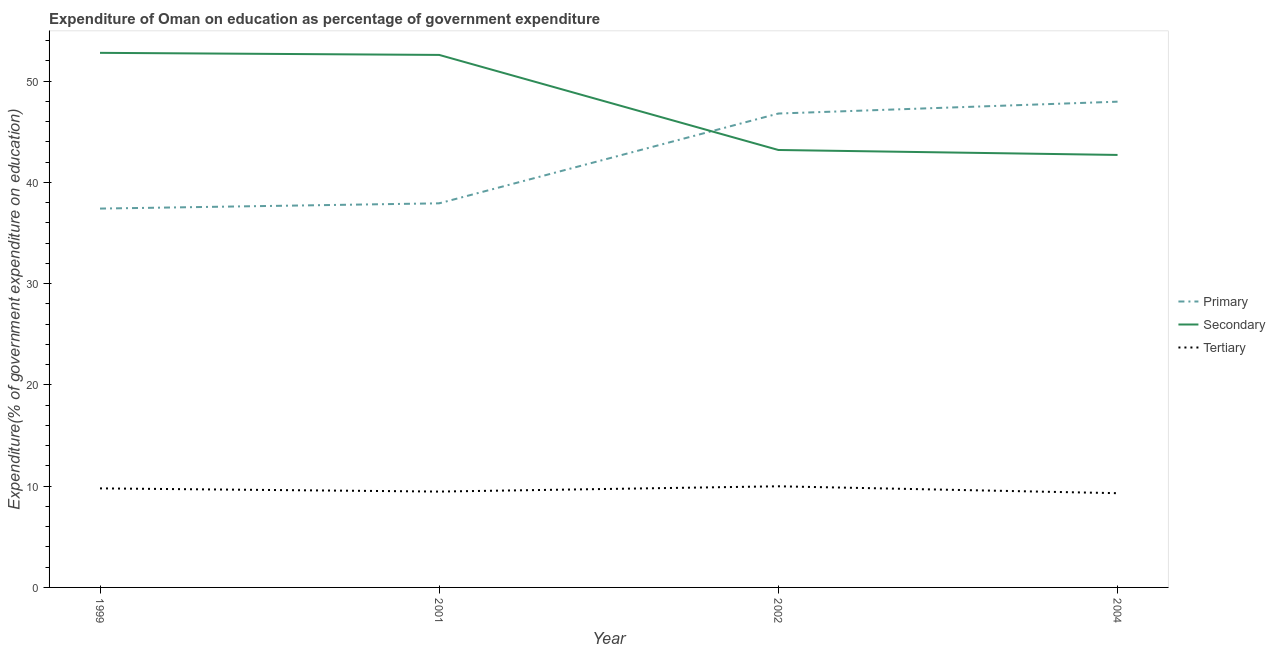How many different coloured lines are there?
Offer a terse response. 3. Is the number of lines equal to the number of legend labels?
Provide a succinct answer. Yes. What is the expenditure on tertiary education in 2004?
Make the answer very short. 9.31. Across all years, what is the maximum expenditure on secondary education?
Your response must be concise. 52.8. Across all years, what is the minimum expenditure on secondary education?
Provide a succinct answer. 42.72. In which year was the expenditure on primary education maximum?
Your answer should be very brief. 2004. What is the total expenditure on primary education in the graph?
Offer a terse response. 170.14. What is the difference between the expenditure on tertiary education in 1999 and that in 2002?
Your response must be concise. -0.21. What is the difference between the expenditure on tertiary education in 1999 and the expenditure on secondary education in 2001?
Your answer should be very brief. -42.81. What is the average expenditure on tertiary education per year?
Your answer should be compact. 9.64. In the year 2001, what is the difference between the expenditure on primary education and expenditure on tertiary education?
Keep it short and to the point. 28.47. What is the ratio of the expenditure on tertiary education in 1999 to that in 2004?
Your answer should be compact. 1.05. What is the difference between the highest and the second highest expenditure on primary education?
Keep it short and to the point. 1.17. What is the difference between the highest and the lowest expenditure on tertiary education?
Offer a very short reply. 0.68. In how many years, is the expenditure on secondary education greater than the average expenditure on secondary education taken over all years?
Offer a very short reply. 2. Is it the case that in every year, the sum of the expenditure on primary education and expenditure on secondary education is greater than the expenditure on tertiary education?
Provide a succinct answer. Yes. Does the expenditure on tertiary education monotonically increase over the years?
Your answer should be compact. No. Is the expenditure on primary education strictly greater than the expenditure on tertiary education over the years?
Your response must be concise. Yes. Is the expenditure on tertiary education strictly less than the expenditure on secondary education over the years?
Provide a succinct answer. Yes. What is the difference between two consecutive major ticks on the Y-axis?
Provide a succinct answer. 10. Are the values on the major ticks of Y-axis written in scientific E-notation?
Provide a succinct answer. No. Where does the legend appear in the graph?
Keep it short and to the point. Center right. How many legend labels are there?
Keep it short and to the point. 3. What is the title of the graph?
Provide a succinct answer. Expenditure of Oman on education as percentage of government expenditure. Does "Agricultural raw materials" appear as one of the legend labels in the graph?
Make the answer very short. No. What is the label or title of the Y-axis?
Offer a terse response. Expenditure(% of government expenditure on education). What is the Expenditure(% of government expenditure on education) of Primary in 1999?
Ensure brevity in your answer.  37.42. What is the Expenditure(% of government expenditure on education) of Secondary in 1999?
Provide a succinct answer. 52.8. What is the Expenditure(% of government expenditure on education) in Tertiary in 1999?
Keep it short and to the point. 9.78. What is the Expenditure(% of government expenditure on education) of Primary in 2001?
Offer a very short reply. 37.94. What is the Expenditure(% of government expenditure on education) in Secondary in 2001?
Provide a succinct answer. 52.59. What is the Expenditure(% of government expenditure on education) in Tertiary in 2001?
Offer a very short reply. 9.47. What is the Expenditure(% of government expenditure on education) in Primary in 2002?
Give a very brief answer. 46.81. What is the Expenditure(% of government expenditure on education) of Secondary in 2002?
Provide a succinct answer. 43.21. What is the Expenditure(% of government expenditure on education) of Tertiary in 2002?
Keep it short and to the point. 9.99. What is the Expenditure(% of government expenditure on education) of Primary in 2004?
Your answer should be very brief. 47.98. What is the Expenditure(% of government expenditure on education) of Secondary in 2004?
Your answer should be very brief. 42.72. What is the Expenditure(% of government expenditure on education) of Tertiary in 2004?
Your response must be concise. 9.31. Across all years, what is the maximum Expenditure(% of government expenditure on education) in Primary?
Keep it short and to the point. 47.98. Across all years, what is the maximum Expenditure(% of government expenditure on education) in Secondary?
Make the answer very short. 52.8. Across all years, what is the maximum Expenditure(% of government expenditure on education) of Tertiary?
Provide a succinct answer. 9.99. Across all years, what is the minimum Expenditure(% of government expenditure on education) in Primary?
Your answer should be very brief. 37.42. Across all years, what is the minimum Expenditure(% of government expenditure on education) in Secondary?
Provide a short and direct response. 42.72. Across all years, what is the minimum Expenditure(% of government expenditure on education) of Tertiary?
Offer a terse response. 9.31. What is the total Expenditure(% of government expenditure on education) of Primary in the graph?
Keep it short and to the point. 170.14. What is the total Expenditure(% of government expenditure on education) in Secondary in the graph?
Make the answer very short. 191.32. What is the total Expenditure(% of government expenditure on education) in Tertiary in the graph?
Provide a short and direct response. 38.55. What is the difference between the Expenditure(% of government expenditure on education) in Primary in 1999 and that in 2001?
Provide a succinct answer. -0.52. What is the difference between the Expenditure(% of government expenditure on education) in Secondary in 1999 and that in 2001?
Your answer should be compact. 0.21. What is the difference between the Expenditure(% of government expenditure on education) in Tertiary in 1999 and that in 2001?
Your response must be concise. 0.31. What is the difference between the Expenditure(% of government expenditure on education) in Primary in 1999 and that in 2002?
Your answer should be compact. -9.39. What is the difference between the Expenditure(% of government expenditure on education) of Secondary in 1999 and that in 2002?
Keep it short and to the point. 9.59. What is the difference between the Expenditure(% of government expenditure on education) in Tertiary in 1999 and that in 2002?
Offer a terse response. -0.21. What is the difference between the Expenditure(% of government expenditure on education) in Primary in 1999 and that in 2004?
Keep it short and to the point. -10.56. What is the difference between the Expenditure(% of government expenditure on education) of Secondary in 1999 and that in 2004?
Make the answer very short. 10.08. What is the difference between the Expenditure(% of government expenditure on education) of Tertiary in 1999 and that in 2004?
Offer a terse response. 0.48. What is the difference between the Expenditure(% of government expenditure on education) in Primary in 2001 and that in 2002?
Provide a short and direct response. -8.87. What is the difference between the Expenditure(% of government expenditure on education) in Secondary in 2001 and that in 2002?
Your answer should be very brief. 9.39. What is the difference between the Expenditure(% of government expenditure on education) in Tertiary in 2001 and that in 2002?
Give a very brief answer. -0.52. What is the difference between the Expenditure(% of government expenditure on education) of Primary in 2001 and that in 2004?
Give a very brief answer. -10.04. What is the difference between the Expenditure(% of government expenditure on education) in Secondary in 2001 and that in 2004?
Your answer should be compact. 9.88. What is the difference between the Expenditure(% of government expenditure on education) of Tertiary in 2001 and that in 2004?
Provide a succinct answer. 0.16. What is the difference between the Expenditure(% of government expenditure on education) in Primary in 2002 and that in 2004?
Give a very brief answer. -1.17. What is the difference between the Expenditure(% of government expenditure on education) in Secondary in 2002 and that in 2004?
Offer a terse response. 0.49. What is the difference between the Expenditure(% of government expenditure on education) of Tertiary in 2002 and that in 2004?
Provide a short and direct response. 0.68. What is the difference between the Expenditure(% of government expenditure on education) of Primary in 1999 and the Expenditure(% of government expenditure on education) of Secondary in 2001?
Provide a succinct answer. -15.18. What is the difference between the Expenditure(% of government expenditure on education) in Primary in 1999 and the Expenditure(% of government expenditure on education) in Tertiary in 2001?
Offer a terse response. 27.95. What is the difference between the Expenditure(% of government expenditure on education) of Secondary in 1999 and the Expenditure(% of government expenditure on education) of Tertiary in 2001?
Your response must be concise. 43.33. What is the difference between the Expenditure(% of government expenditure on education) in Primary in 1999 and the Expenditure(% of government expenditure on education) in Secondary in 2002?
Make the answer very short. -5.79. What is the difference between the Expenditure(% of government expenditure on education) in Primary in 1999 and the Expenditure(% of government expenditure on education) in Tertiary in 2002?
Your response must be concise. 27.43. What is the difference between the Expenditure(% of government expenditure on education) in Secondary in 1999 and the Expenditure(% of government expenditure on education) in Tertiary in 2002?
Offer a terse response. 42.81. What is the difference between the Expenditure(% of government expenditure on education) in Primary in 1999 and the Expenditure(% of government expenditure on education) in Secondary in 2004?
Keep it short and to the point. -5.3. What is the difference between the Expenditure(% of government expenditure on education) in Primary in 1999 and the Expenditure(% of government expenditure on education) in Tertiary in 2004?
Provide a short and direct response. 28.11. What is the difference between the Expenditure(% of government expenditure on education) of Secondary in 1999 and the Expenditure(% of government expenditure on education) of Tertiary in 2004?
Your response must be concise. 43.49. What is the difference between the Expenditure(% of government expenditure on education) of Primary in 2001 and the Expenditure(% of government expenditure on education) of Secondary in 2002?
Your response must be concise. -5.27. What is the difference between the Expenditure(% of government expenditure on education) in Primary in 2001 and the Expenditure(% of government expenditure on education) in Tertiary in 2002?
Your response must be concise. 27.95. What is the difference between the Expenditure(% of government expenditure on education) of Secondary in 2001 and the Expenditure(% of government expenditure on education) of Tertiary in 2002?
Provide a short and direct response. 42.61. What is the difference between the Expenditure(% of government expenditure on education) of Primary in 2001 and the Expenditure(% of government expenditure on education) of Secondary in 2004?
Provide a short and direct response. -4.78. What is the difference between the Expenditure(% of government expenditure on education) in Primary in 2001 and the Expenditure(% of government expenditure on education) in Tertiary in 2004?
Your answer should be very brief. 28.63. What is the difference between the Expenditure(% of government expenditure on education) of Secondary in 2001 and the Expenditure(% of government expenditure on education) of Tertiary in 2004?
Your answer should be compact. 43.29. What is the difference between the Expenditure(% of government expenditure on education) in Primary in 2002 and the Expenditure(% of government expenditure on education) in Secondary in 2004?
Make the answer very short. 4.09. What is the difference between the Expenditure(% of government expenditure on education) of Primary in 2002 and the Expenditure(% of government expenditure on education) of Tertiary in 2004?
Offer a very short reply. 37.5. What is the difference between the Expenditure(% of government expenditure on education) of Secondary in 2002 and the Expenditure(% of government expenditure on education) of Tertiary in 2004?
Your answer should be compact. 33.9. What is the average Expenditure(% of government expenditure on education) in Primary per year?
Make the answer very short. 42.53. What is the average Expenditure(% of government expenditure on education) of Secondary per year?
Give a very brief answer. 47.83. What is the average Expenditure(% of government expenditure on education) of Tertiary per year?
Your answer should be compact. 9.64. In the year 1999, what is the difference between the Expenditure(% of government expenditure on education) in Primary and Expenditure(% of government expenditure on education) in Secondary?
Keep it short and to the point. -15.38. In the year 1999, what is the difference between the Expenditure(% of government expenditure on education) in Primary and Expenditure(% of government expenditure on education) in Tertiary?
Ensure brevity in your answer.  27.64. In the year 1999, what is the difference between the Expenditure(% of government expenditure on education) in Secondary and Expenditure(% of government expenditure on education) in Tertiary?
Give a very brief answer. 43.02. In the year 2001, what is the difference between the Expenditure(% of government expenditure on education) in Primary and Expenditure(% of government expenditure on education) in Secondary?
Make the answer very short. -14.66. In the year 2001, what is the difference between the Expenditure(% of government expenditure on education) in Primary and Expenditure(% of government expenditure on education) in Tertiary?
Provide a succinct answer. 28.47. In the year 2001, what is the difference between the Expenditure(% of government expenditure on education) of Secondary and Expenditure(% of government expenditure on education) of Tertiary?
Your answer should be compact. 43.13. In the year 2002, what is the difference between the Expenditure(% of government expenditure on education) in Primary and Expenditure(% of government expenditure on education) in Secondary?
Offer a very short reply. 3.6. In the year 2002, what is the difference between the Expenditure(% of government expenditure on education) of Primary and Expenditure(% of government expenditure on education) of Tertiary?
Make the answer very short. 36.82. In the year 2002, what is the difference between the Expenditure(% of government expenditure on education) in Secondary and Expenditure(% of government expenditure on education) in Tertiary?
Provide a short and direct response. 33.22. In the year 2004, what is the difference between the Expenditure(% of government expenditure on education) of Primary and Expenditure(% of government expenditure on education) of Secondary?
Make the answer very short. 5.26. In the year 2004, what is the difference between the Expenditure(% of government expenditure on education) of Primary and Expenditure(% of government expenditure on education) of Tertiary?
Offer a very short reply. 38.67. In the year 2004, what is the difference between the Expenditure(% of government expenditure on education) in Secondary and Expenditure(% of government expenditure on education) in Tertiary?
Ensure brevity in your answer.  33.41. What is the ratio of the Expenditure(% of government expenditure on education) of Primary in 1999 to that in 2001?
Your answer should be compact. 0.99. What is the ratio of the Expenditure(% of government expenditure on education) of Secondary in 1999 to that in 2001?
Your answer should be very brief. 1. What is the ratio of the Expenditure(% of government expenditure on education) of Tertiary in 1999 to that in 2001?
Your answer should be very brief. 1.03. What is the ratio of the Expenditure(% of government expenditure on education) of Primary in 1999 to that in 2002?
Your answer should be very brief. 0.8. What is the ratio of the Expenditure(% of government expenditure on education) in Secondary in 1999 to that in 2002?
Offer a terse response. 1.22. What is the ratio of the Expenditure(% of government expenditure on education) in Tertiary in 1999 to that in 2002?
Keep it short and to the point. 0.98. What is the ratio of the Expenditure(% of government expenditure on education) of Primary in 1999 to that in 2004?
Your response must be concise. 0.78. What is the ratio of the Expenditure(% of government expenditure on education) in Secondary in 1999 to that in 2004?
Provide a succinct answer. 1.24. What is the ratio of the Expenditure(% of government expenditure on education) in Tertiary in 1999 to that in 2004?
Your response must be concise. 1.05. What is the ratio of the Expenditure(% of government expenditure on education) of Primary in 2001 to that in 2002?
Your response must be concise. 0.81. What is the ratio of the Expenditure(% of government expenditure on education) of Secondary in 2001 to that in 2002?
Offer a terse response. 1.22. What is the ratio of the Expenditure(% of government expenditure on education) in Tertiary in 2001 to that in 2002?
Your answer should be very brief. 0.95. What is the ratio of the Expenditure(% of government expenditure on education) in Primary in 2001 to that in 2004?
Provide a short and direct response. 0.79. What is the ratio of the Expenditure(% of government expenditure on education) in Secondary in 2001 to that in 2004?
Your response must be concise. 1.23. What is the ratio of the Expenditure(% of government expenditure on education) in Tertiary in 2001 to that in 2004?
Give a very brief answer. 1.02. What is the ratio of the Expenditure(% of government expenditure on education) of Primary in 2002 to that in 2004?
Your answer should be compact. 0.98. What is the ratio of the Expenditure(% of government expenditure on education) in Secondary in 2002 to that in 2004?
Offer a terse response. 1.01. What is the ratio of the Expenditure(% of government expenditure on education) of Tertiary in 2002 to that in 2004?
Ensure brevity in your answer.  1.07. What is the difference between the highest and the second highest Expenditure(% of government expenditure on education) in Primary?
Ensure brevity in your answer.  1.17. What is the difference between the highest and the second highest Expenditure(% of government expenditure on education) of Secondary?
Ensure brevity in your answer.  0.21. What is the difference between the highest and the second highest Expenditure(% of government expenditure on education) in Tertiary?
Your response must be concise. 0.21. What is the difference between the highest and the lowest Expenditure(% of government expenditure on education) of Primary?
Your answer should be very brief. 10.56. What is the difference between the highest and the lowest Expenditure(% of government expenditure on education) in Secondary?
Make the answer very short. 10.08. What is the difference between the highest and the lowest Expenditure(% of government expenditure on education) in Tertiary?
Keep it short and to the point. 0.68. 